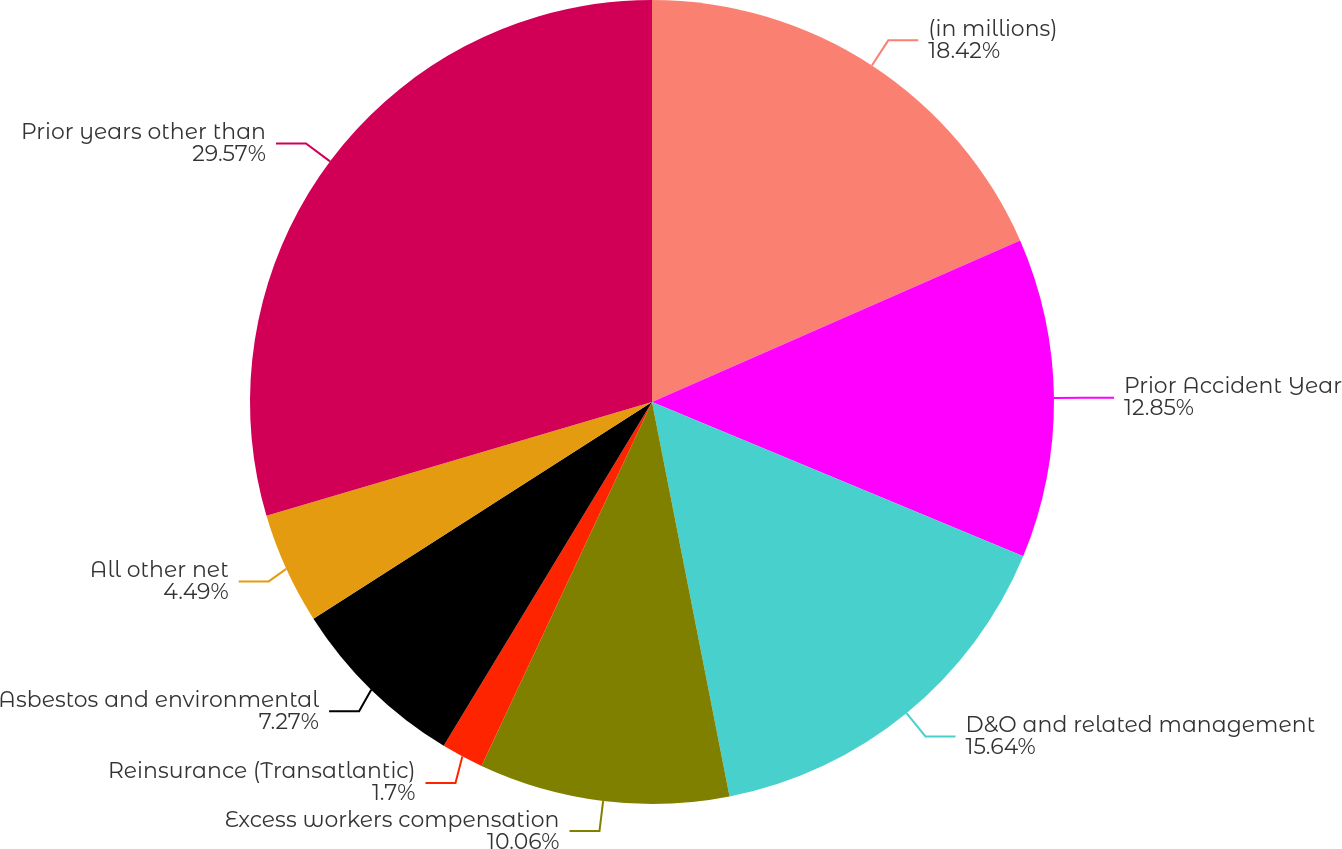Convert chart. <chart><loc_0><loc_0><loc_500><loc_500><pie_chart><fcel>(in millions)<fcel>Prior Accident Year<fcel>D&O and related management<fcel>Excess workers compensation<fcel>Reinsurance (Transatlantic)<fcel>Asbestos and environmental<fcel>All other net<fcel>Prior years other than<nl><fcel>18.42%<fcel>12.85%<fcel>15.64%<fcel>10.06%<fcel>1.7%<fcel>7.27%<fcel>4.49%<fcel>29.57%<nl></chart> 